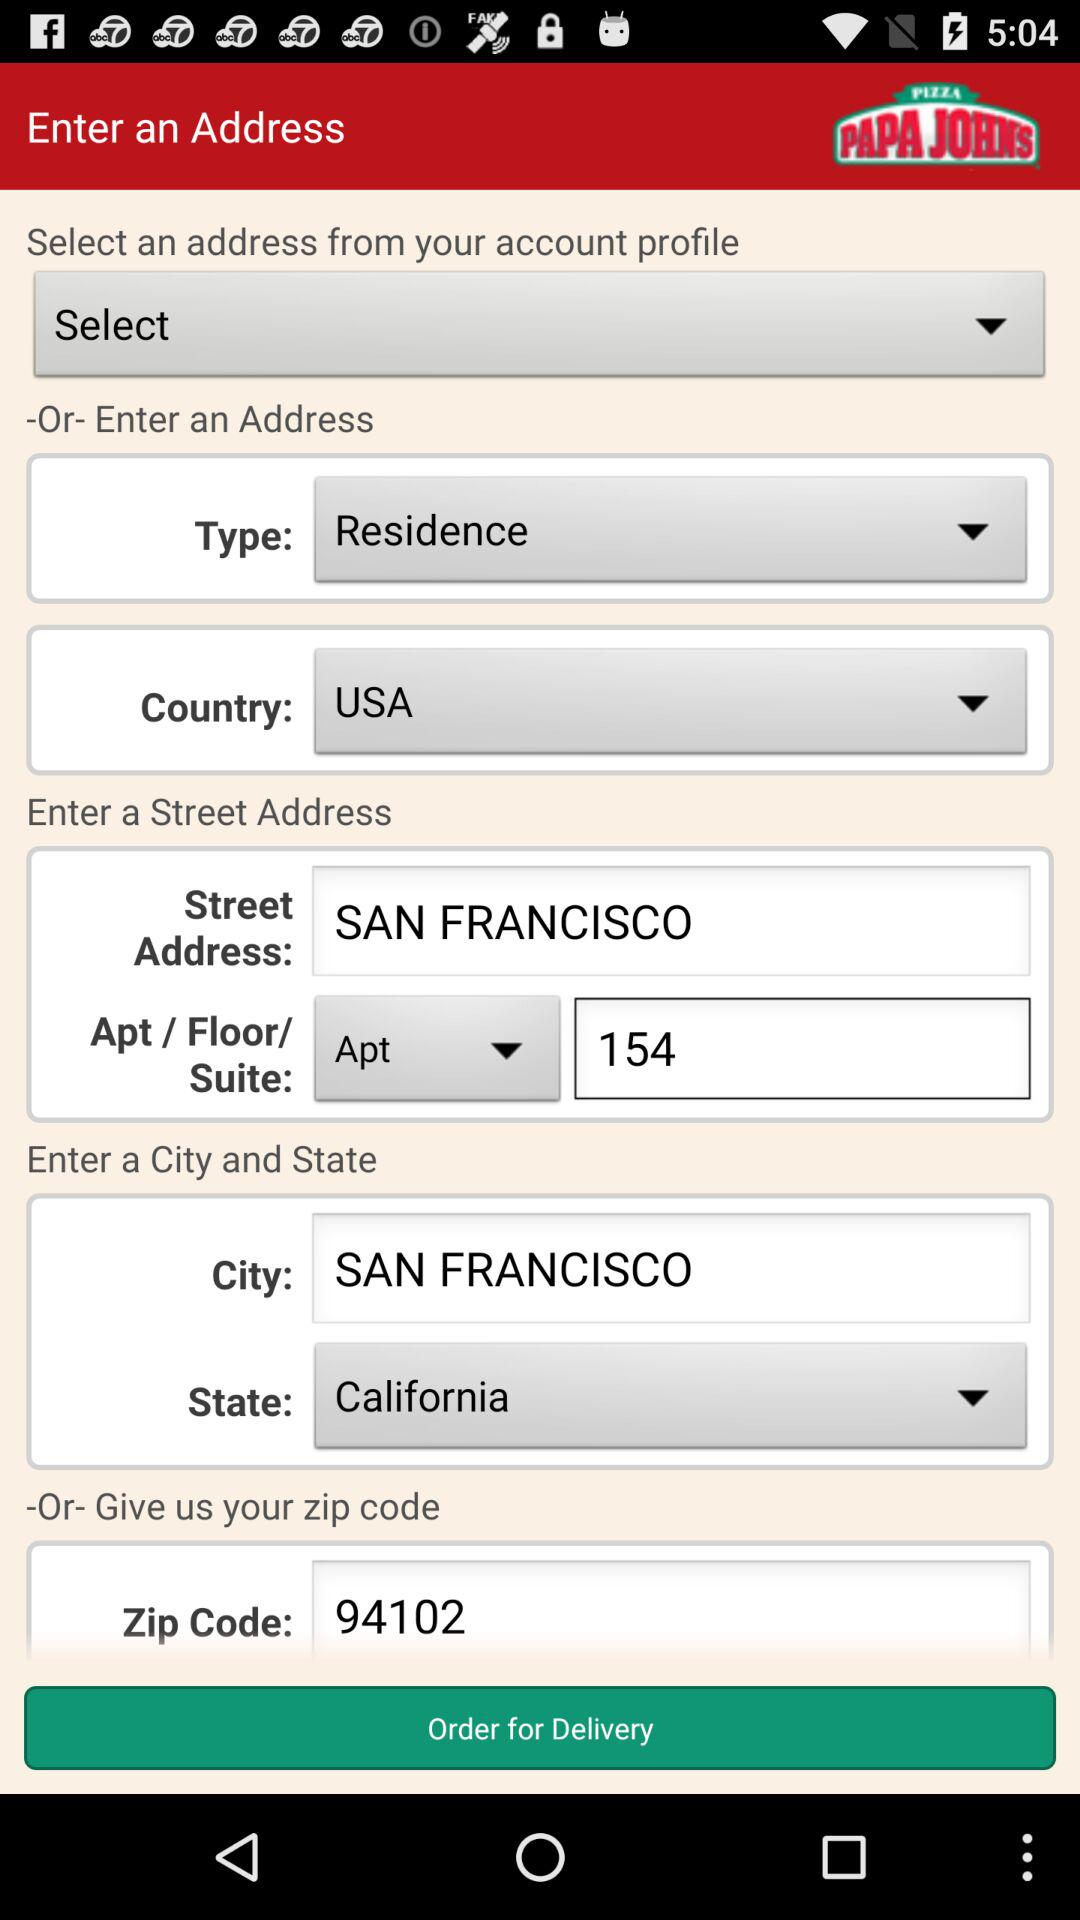What is the street address? The street address is Apartment 154, San Francisco. 